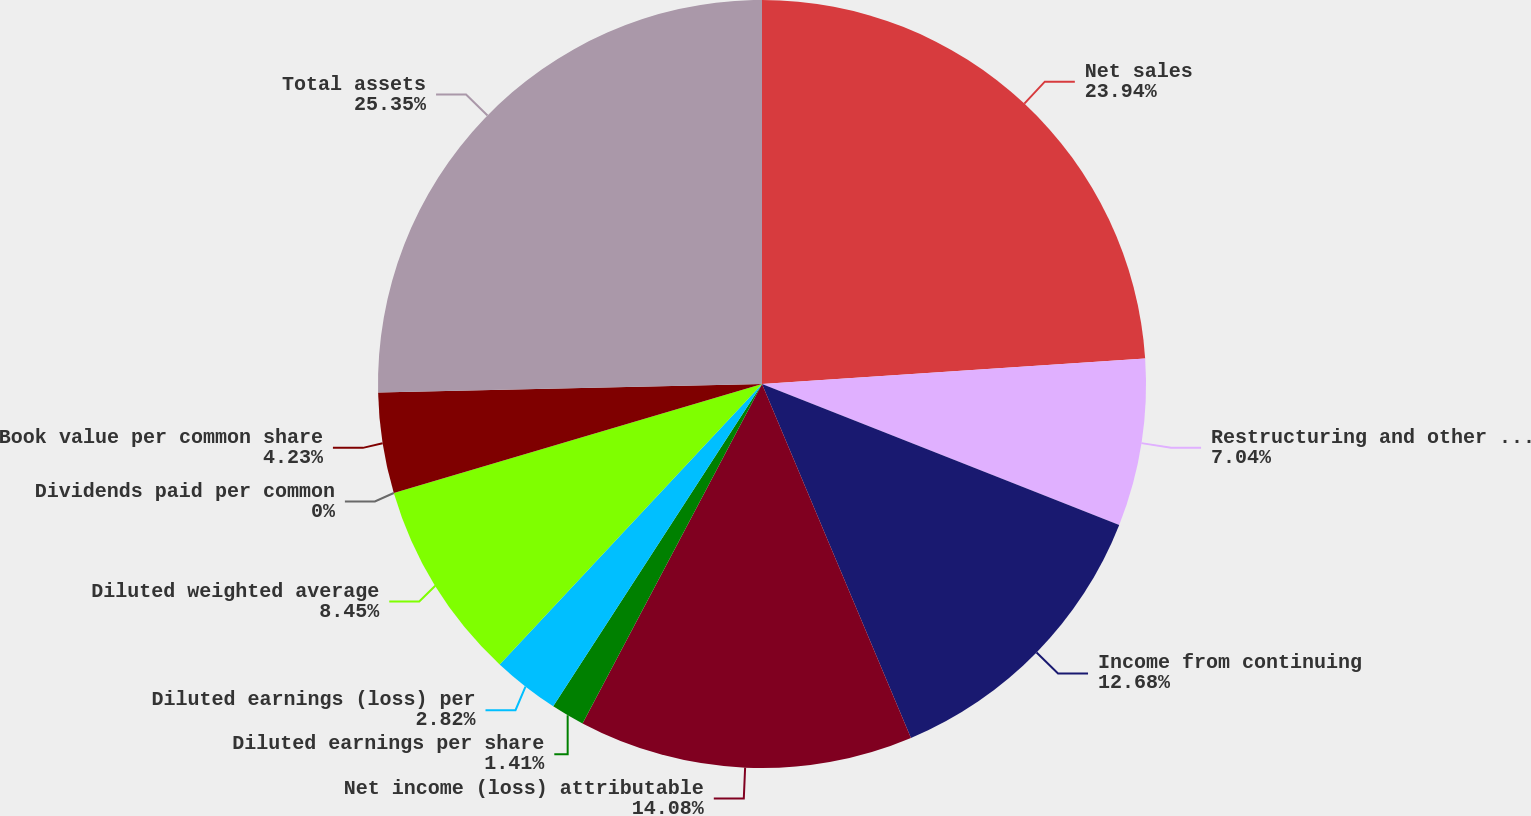<chart> <loc_0><loc_0><loc_500><loc_500><pie_chart><fcel>Net sales<fcel>Restructuring and other costs<fcel>Income from continuing<fcel>Net income (loss) attributable<fcel>Diluted earnings per share<fcel>Diluted earnings (loss) per<fcel>Diluted weighted average<fcel>Dividends paid per common<fcel>Book value per common share<fcel>Total assets<nl><fcel>23.94%<fcel>7.04%<fcel>12.68%<fcel>14.08%<fcel>1.41%<fcel>2.82%<fcel>8.45%<fcel>0.0%<fcel>4.23%<fcel>25.35%<nl></chart> 